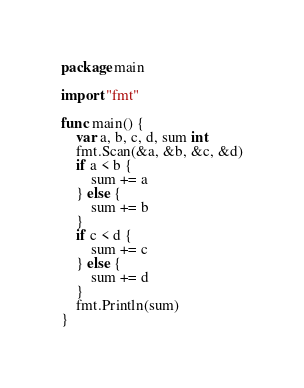<code> <loc_0><loc_0><loc_500><loc_500><_Go_>package main

import "fmt"

func main() {
	var a, b, c, d, sum int
	fmt.Scan(&a, &b, &c, &d)
	if a < b {
		sum += a
	} else {
		sum += b
	}
	if c < d {
		sum += c
	} else {
		sum += d
	}
	fmt.Println(sum)
}
</code> 